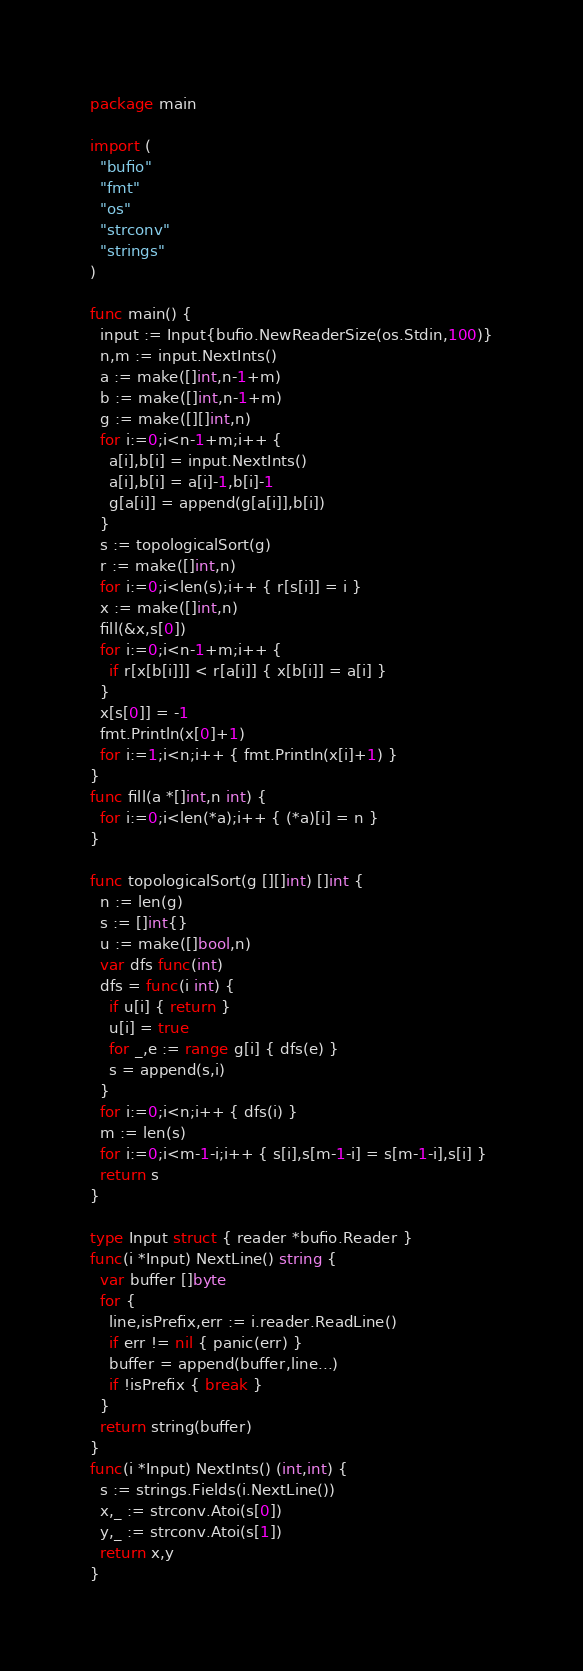Convert code to text. <code><loc_0><loc_0><loc_500><loc_500><_Go_>package main

import (
  "bufio"
  "fmt"
  "os"
  "strconv"
  "strings"
)

func main() {
  input := Input{bufio.NewReaderSize(os.Stdin,100)}
  n,m := input.NextInts()
  a := make([]int,n-1+m)
  b := make([]int,n-1+m)
  g := make([][]int,n)
  for i:=0;i<n-1+m;i++ {
    a[i],b[i] = input.NextInts()
    a[i],b[i] = a[i]-1,b[i]-1
    g[a[i]] = append(g[a[i]],b[i])
  }
  s := topologicalSort(g)
  r := make([]int,n)
  for i:=0;i<len(s);i++ { r[s[i]] = i }
  x := make([]int,n)
  fill(&x,s[0])
  for i:=0;i<n-1+m;i++ {
    if r[x[b[i]]] < r[a[i]] { x[b[i]] = a[i] }
  }
  x[s[0]] = -1
  fmt.Println(x[0]+1)
  for i:=1;i<n;i++ { fmt.Println(x[i]+1) }
}
func fill(a *[]int,n int) {
  for i:=0;i<len(*a);i++ { (*a)[i] = n }
}

func topologicalSort(g [][]int) []int {
  n := len(g)
  s := []int{}
  u := make([]bool,n)
  var dfs func(int)
  dfs = func(i int) {
    if u[i] { return }
    u[i] = true
    for _,e := range g[i] { dfs(e) }
    s = append(s,i)
  }
  for i:=0;i<n;i++ { dfs(i) }
  m := len(s)
  for i:=0;i<m-1-i;i++ { s[i],s[m-1-i] = s[m-1-i],s[i] }
  return s
}

type Input struct { reader *bufio.Reader }
func(i *Input) NextLine() string {
  var buffer []byte
  for {
    line,isPrefix,err := i.reader.ReadLine()
    if err != nil { panic(err) }
    buffer = append(buffer,line...)
    if !isPrefix { break }
  }
  return string(buffer)
}
func(i *Input) NextInts() (int,int) {
  s := strings.Fields(i.NextLine())
  x,_ := strconv.Atoi(s[0])
  y,_ := strconv.Atoi(s[1])
  return x,y
}</code> 